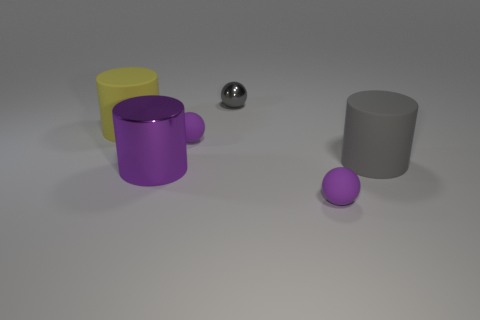There is a object that is both to the left of the gray shiny sphere and on the right side of the big shiny thing; what is its shape?
Give a very brief answer. Sphere. There is a matte cylinder that is the same size as the gray rubber thing; what is its color?
Your answer should be very brief. Yellow. What number of objects are gray spheres or small matte objects?
Give a very brief answer. 3. There is a tiny gray object; are there any purple metal things behind it?
Provide a succinct answer. No. Are there any purple objects made of the same material as the small gray object?
Provide a short and direct response. Yes. What number of balls are either purple rubber things or yellow objects?
Ensure brevity in your answer.  2. Are there more small purple matte spheres that are in front of the large purple shiny cylinder than purple shiny cylinders behind the gray cylinder?
Offer a terse response. Yes. What number of matte objects have the same color as the large metal thing?
Your answer should be compact. 2. What is the size of the cylinder that is made of the same material as the large gray object?
Keep it short and to the point. Large. How many things are either objects behind the yellow cylinder or big brown objects?
Keep it short and to the point. 1. 